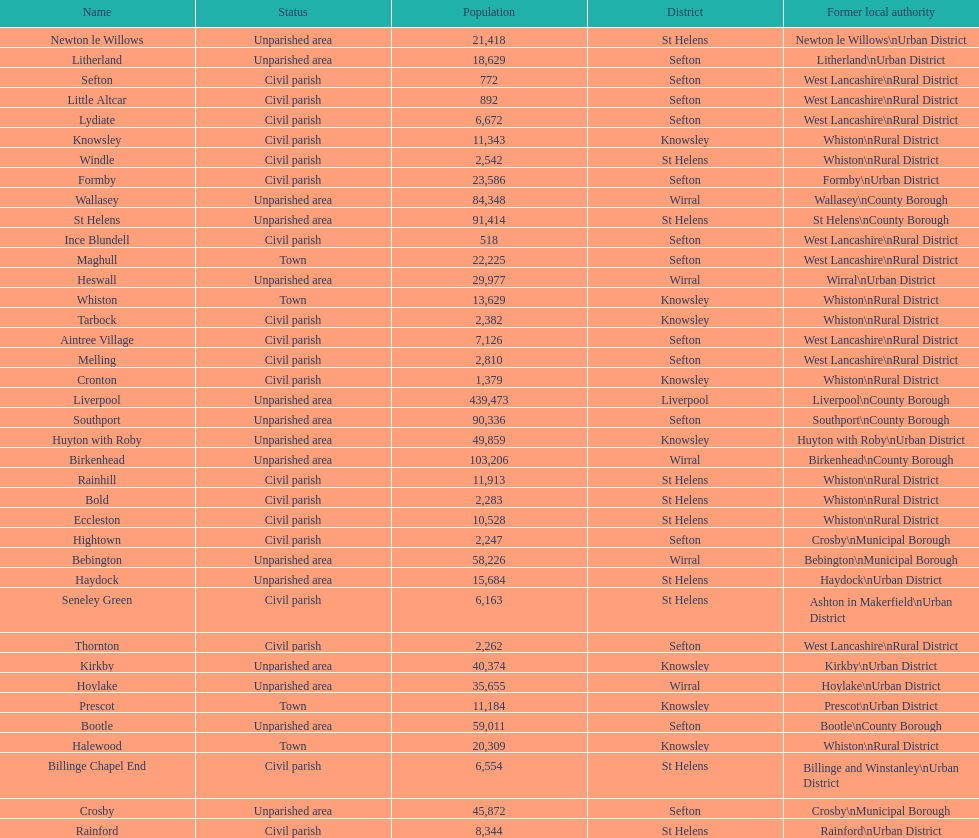What is the largest area in terms of population? Liverpool. 